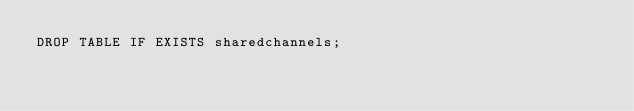<code> <loc_0><loc_0><loc_500><loc_500><_SQL_>DROP TABLE IF EXISTS sharedchannels;
</code> 